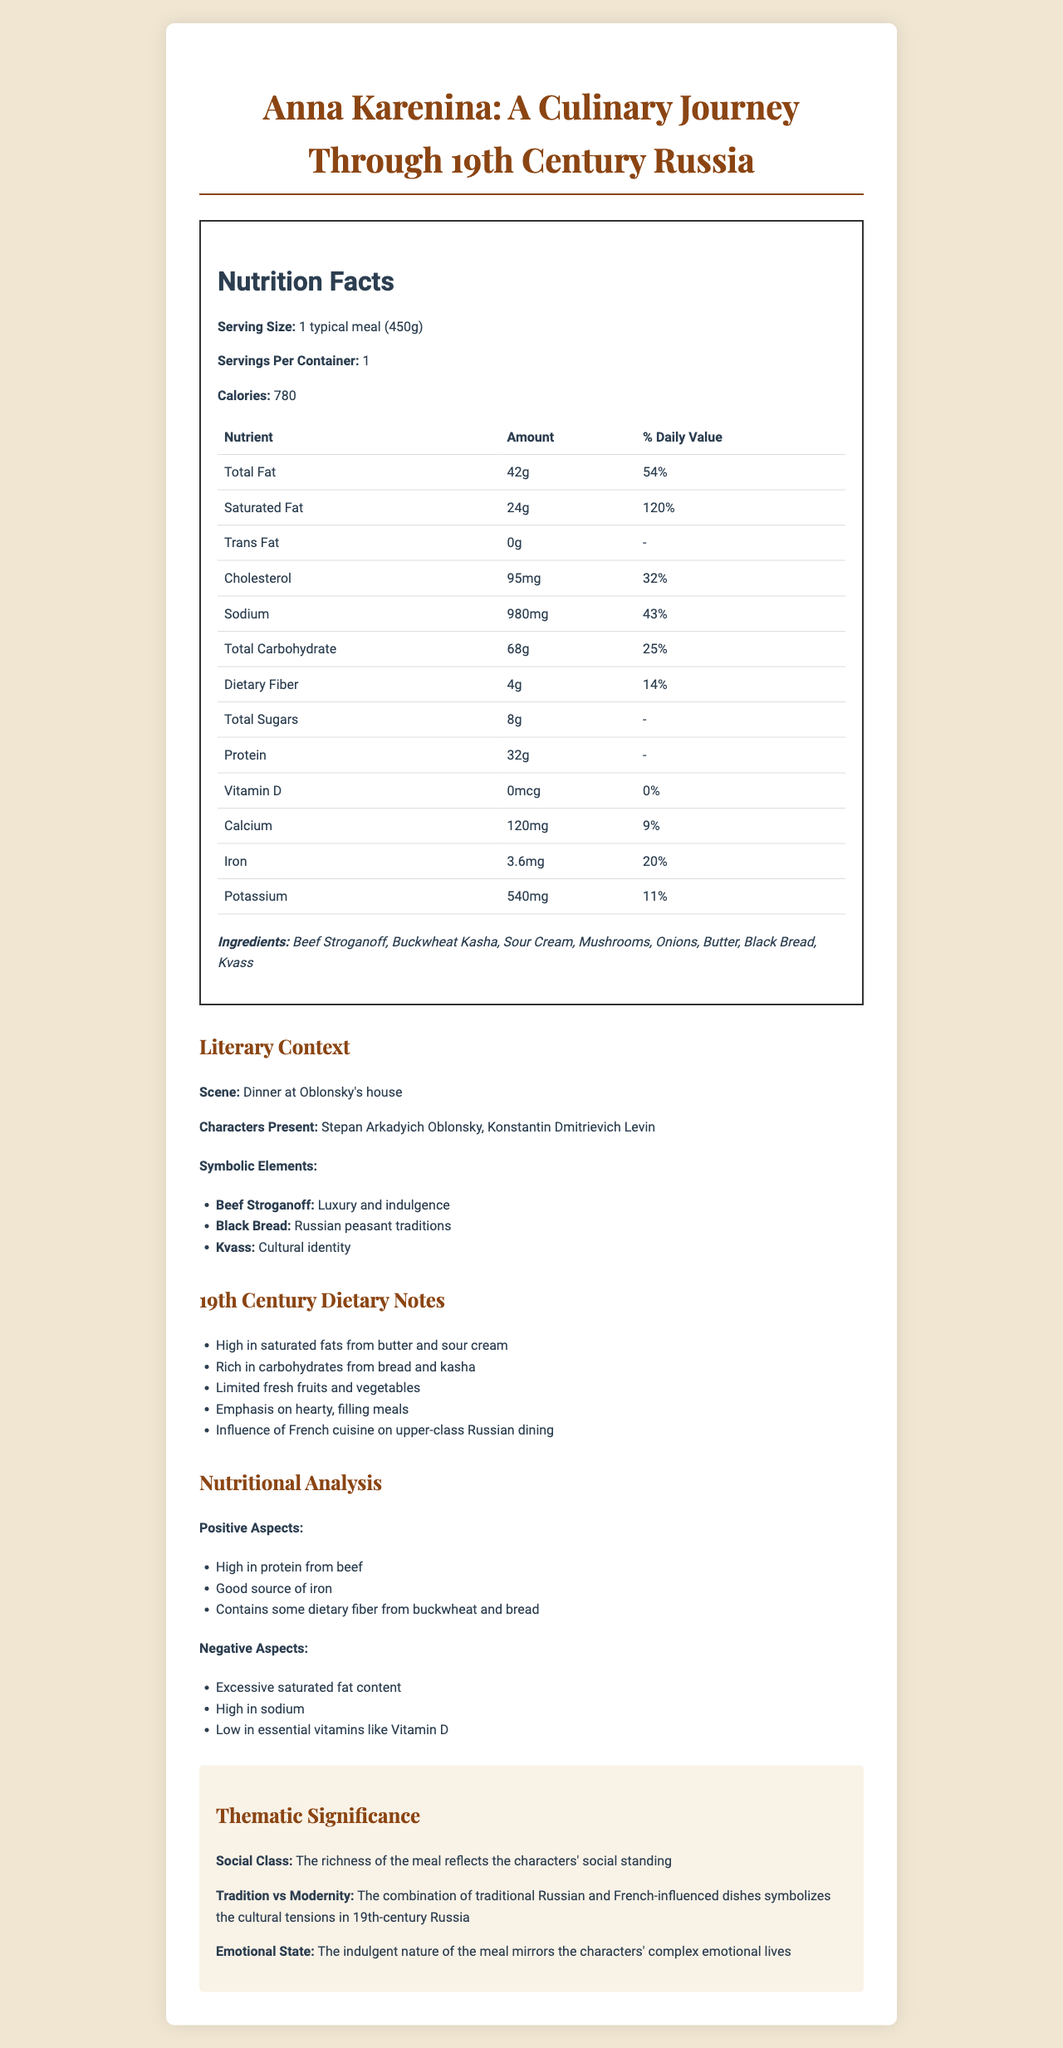what is the serving size for the meal? The document specifies a serving size of 1 typical meal (450g).
Answer: 1 typical meal (450g) how many calories are in one serving? According to the Nutrition Facts section, one serving contains 780 calories.
Answer: 780 what is the percentage daily value of total fat in the meal? The document states that the total fat content is 42g, constituting 54% of the daily value.
Answer: 54% how much protein is in one serving of the meal? The protein content in one serving is listed as 32g in the Nutrition Facts section.
Answer: 32g which two characters are present in the dinner scene? The Literary Context section identifies Stepan Arkadyich Oblonsky and Konstantin Dmitrievich Levin as the characters present.
Answer: Stepan Arkadyich Oblonsky and Konstantin Dmitrievich Levin which nutrient has the highest daily value percentage? A. Saturated Fat B. Sodium C. Iron D. Cholesterol Saturated Fat has a daily value percentage of 120%, which is higher than Sodium (43%), Iron (20%), and Cholesterol (32%).
Answer: A. Saturated Fat what is one of the traditional Russian elements in the meal? A. Kvass B. Butter C. Mushrooms D. Onions The Literary Context section specifically identifies Kvass as a symbol of cultural identity, reflecting traditional Russian elements.
Answer: A. Kvass does the meal contain any Vitamin D? The nutritional facts state that there is 0% daily value for Vitamin D, indicating none is present.
Answer: No summarize the nutritional positive aspects of the meal. According to the Nutritional Analysis section, the meal has the positive aspects of being high in protein, a good source of iron, and containing dietary fiber.
Answer: High in protein, good source of iron, contains dietary fiber describe the overall theme of the meal in the context of the story. The Thematic Significance section details that the richness of the meal reflects the social standing, the blend of dishes symbolizes cultural tensions, and its indulgent nature mirrors the characters' emotions.
Answer: The meal reflects the richness of the characters' social standing and blends traditional Russian and French-influenced dishes, symbolizing cultural tensions and mirroring the characters' complex emotional lives. what influences french cuisine on upper-class Russian dining as seen in this meal? The document indicates such an influence but does not provide specific dishes or elements that showcase it directly.
Answer: Cannot be determined what is the daily value percentage of calcium in the meal? The Nutrition Facts section lists the calcium content as 120mg, which is 9% of the daily value.
Answer: 9% explain one symbolic element associated with beef stroganoff. The Literary Context section states that beef stroganoff symbolizes luxury and indulgence.
Answer: Luxury and indulgence describe an aspect of 19th-century dietary habits based on the meal's composition. The 19th Century Dietary Notes section details that such meals were high in fats and carbohydrates and were hearty and filling.
Answer: The meal is high in saturated fats from butter and sour cream and rich in carbohydrates from bread and kasha, emphasizing hearty, filling meals typical of the period. 